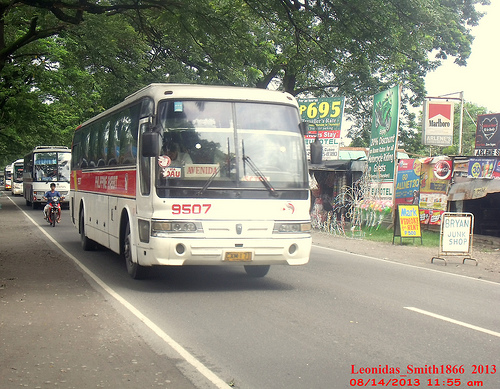Please provide a short description for this region: [0.07, 0.46, 0.14, 0.57]. A man on a motorcycle riding behind the bus on the road. 